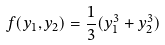<formula> <loc_0><loc_0><loc_500><loc_500>f ( y _ { 1 } , y _ { 2 } ) = \frac { 1 } { 3 } ( y _ { 1 } ^ { 3 } + y _ { 2 } ^ { 3 } )</formula> 